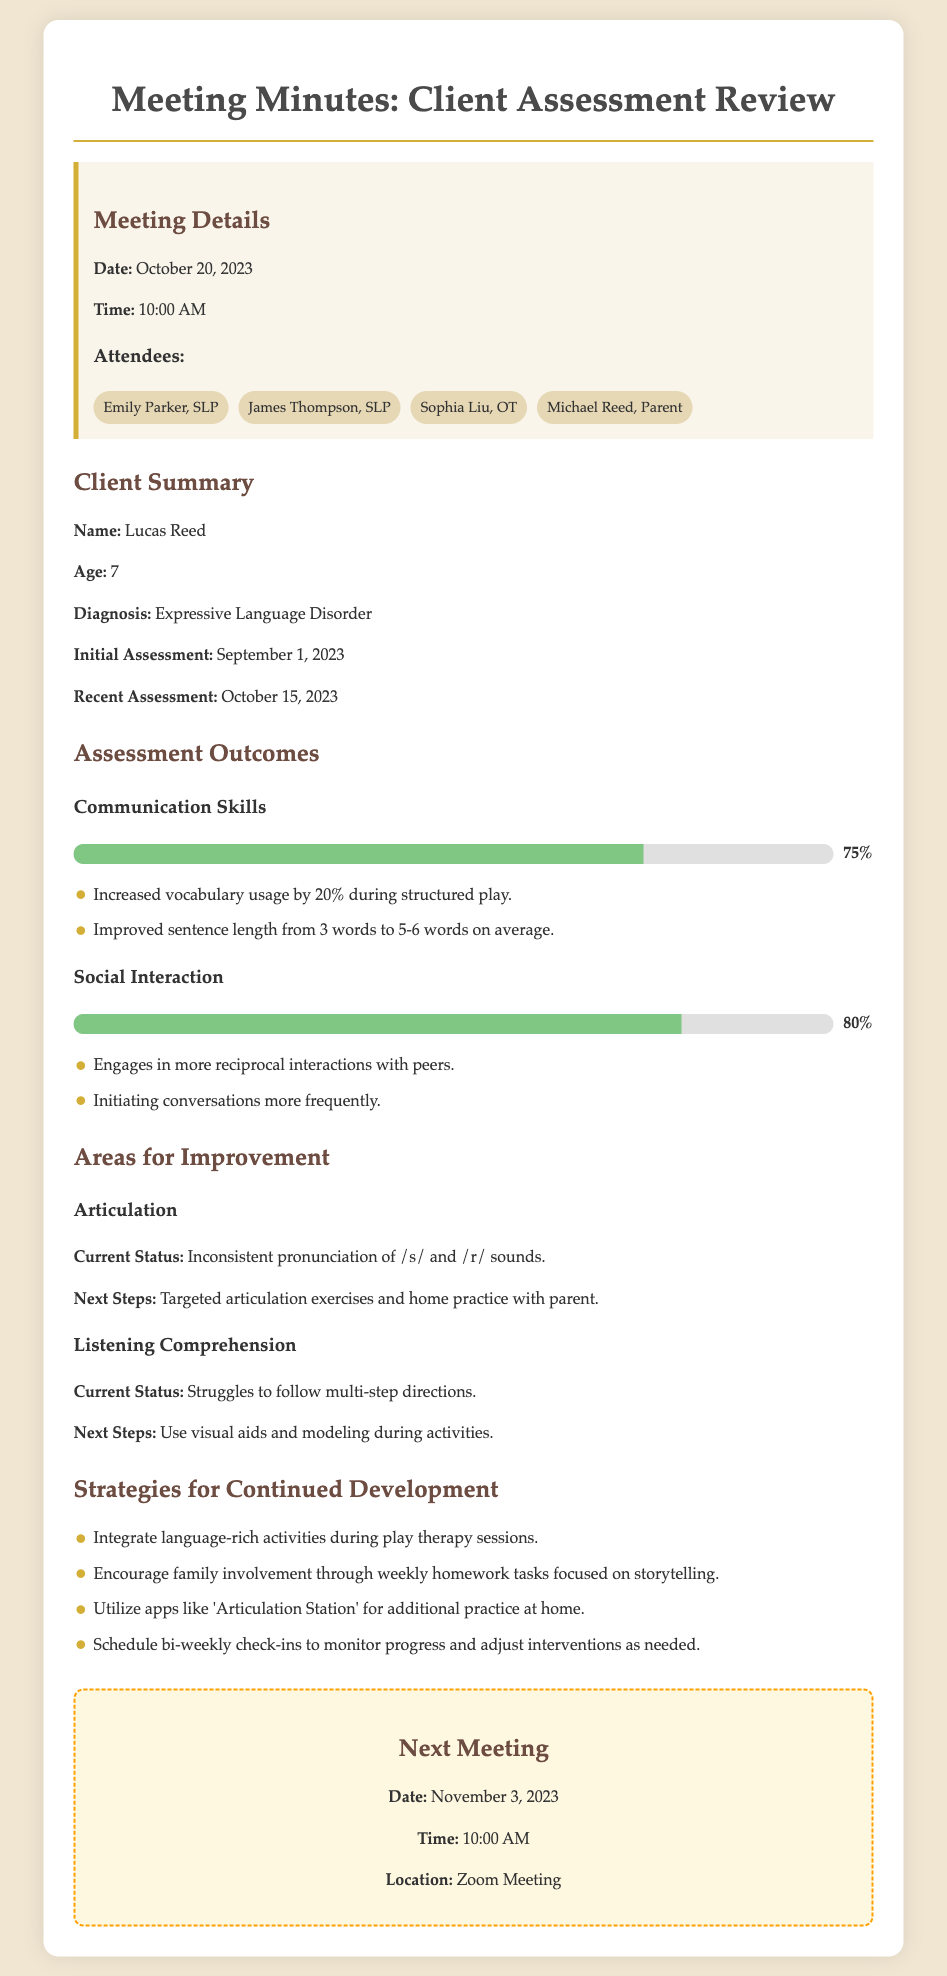What is the client's name? The client’s name is explicitly stated in the document under the client summary section.
Answer: Lucas Reed What is the diagnosis of the client? The diagnosis is mentioned in the client summary section, indicating the nature of the client's condition.
Answer: Expressive Language Disorder When was the recent assessment conducted? The specific date of the recent assessment is provided in the client summary section.
Answer: October 15, 2023 What was the percentage improvement in communication skills? This percentage is directly reported in the assessment outcomes section, under communication skills.
Answer: 75% What are the areas for improvement mentioned? This information is organized under the "Areas for Improvement" heading and requires collecting specifics from the document.
Answer: Articulation and Listening Comprehension What strategies are suggested for continued development? Strategies are listed under their section, detailing supportive measures for the client’s progress.
Answer: Language-rich activities, family involvement, apps, bi-weekly check-ins Who are the attendees of the meeting? The attendees listed show everyone present at the meeting, indicating collaborative effort.
Answer: Emily Parker, James Thompson, Sophia Liu, Michael Reed What is the date and time of the next meeting? This information is clearly stated in the next meeting section for future planning.
Answer: November 3, 2023, 10:00 AM How did Lucas's vocabulary usage improve? This is noted in the assessment outcomes, specifying the effect of the therapy on his vocabulary.
Answer: Increased vocabulary usage by 20% during structured play 